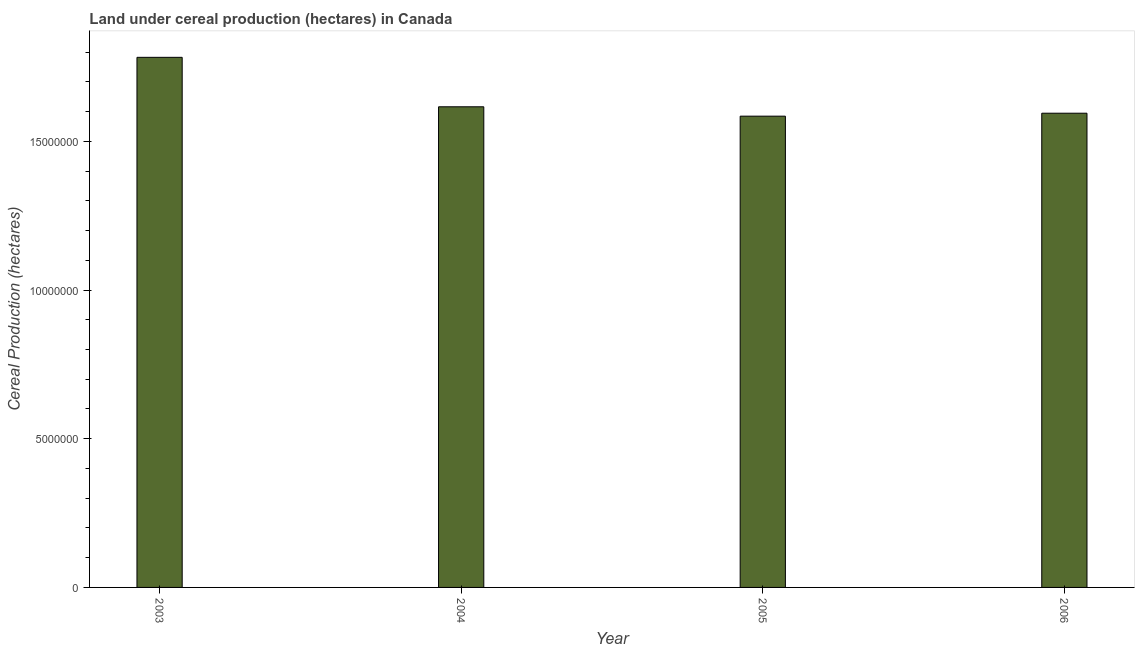Does the graph contain any zero values?
Ensure brevity in your answer.  No. What is the title of the graph?
Your answer should be very brief. Land under cereal production (hectares) in Canada. What is the label or title of the X-axis?
Make the answer very short. Year. What is the label or title of the Y-axis?
Give a very brief answer. Cereal Production (hectares). What is the land under cereal production in 2006?
Provide a short and direct response. 1.59e+07. Across all years, what is the maximum land under cereal production?
Your answer should be very brief. 1.78e+07. Across all years, what is the minimum land under cereal production?
Your answer should be compact. 1.58e+07. In which year was the land under cereal production maximum?
Your answer should be very brief. 2003. What is the sum of the land under cereal production?
Ensure brevity in your answer.  6.58e+07. What is the difference between the land under cereal production in 2003 and 2006?
Keep it short and to the point. 1.88e+06. What is the average land under cereal production per year?
Provide a succinct answer. 1.64e+07. What is the median land under cereal production?
Offer a terse response. 1.61e+07. Do a majority of the years between 2006 and 2004 (inclusive) have land under cereal production greater than 16000000 hectares?
Keep it short and to the point. Yes. What is the ratio of the land under cereal production in 2004 to that in 2006?
Your answer should be compact. 1.01. Is the land under cereal production in 2005 less than that in 2006?
Make the answer very short. Yes. Is the difference between the land under cereal production in 2004 and 2005 greater than the difference between any two years?
Make the answer very short. No. What is the difference between the highest and the second highest land under cereal production?
Provide a short and direct response. 1.66e+06. What is the difference between the highest and the lowest land under cereal production?
Make the answer very short. 1.98e+06. How many bars are there?
Your response must be concise. 4. Are all the bars in the graph horizontal?
Provide a short and direct response. No. What is the difference between two consecutive major ticks on the Y-axis?
Your answer should be compact. 5.00e+06. What is the Cereal Production (hectares) of 2003?
Offer a terse response. 1.78e+07. What is the Cereal Production (hectares) of 2004?
Offer a very short reply. 1.62e+07. What is the Cereal Production (hectares) in 2005?
Provide a short and direct response. 1.58e+07. What is the Cereal Production (hectares) in 2006?
Keep it short and to the point. 1.59e+07. What is the difference between the Cereal Production (hectares) in 2003 and 2004?
Ensure brevity in your answer.  1.66e+06. What is the difference between the Cereal Production (hectares) in 2003 and 2005?
Your answer should be compact. 1.98e+06. What is the difference between the Cereal Production (hectares) in 2003 and 2006?
Give a very brief answer. 1.88e+06. What is the difference between the Cereal Production (hectares) in 2004 and 2005?
Your answer should be compact. 3.15e+05. What is the difference between the Cereal Production (hectares) in 2004 and 2006?
Offer a very short reply. 2.16e+05. What is the difference between the Cereal Production (hectares) in 2005 and 2006?
Provide a succinct answer. -9.93e+04. What is the ratio of the Cereal Production (hectares) in 2003 to that in 2004?
Make the answer very short. 1.1. What is the ratio of the Cereal Production (hectares) in 2003 to that in 2005?
Your answer should be compact. 1.12. What is the ratio of the Cereal Production (hectares) in 2003 to that in 2006?
Your answer should be compact. 1.12. What is the ratio of the Cereal Production (hectares) in 2004 to that in 2006?
Keep it short and to the point. 1.01. 